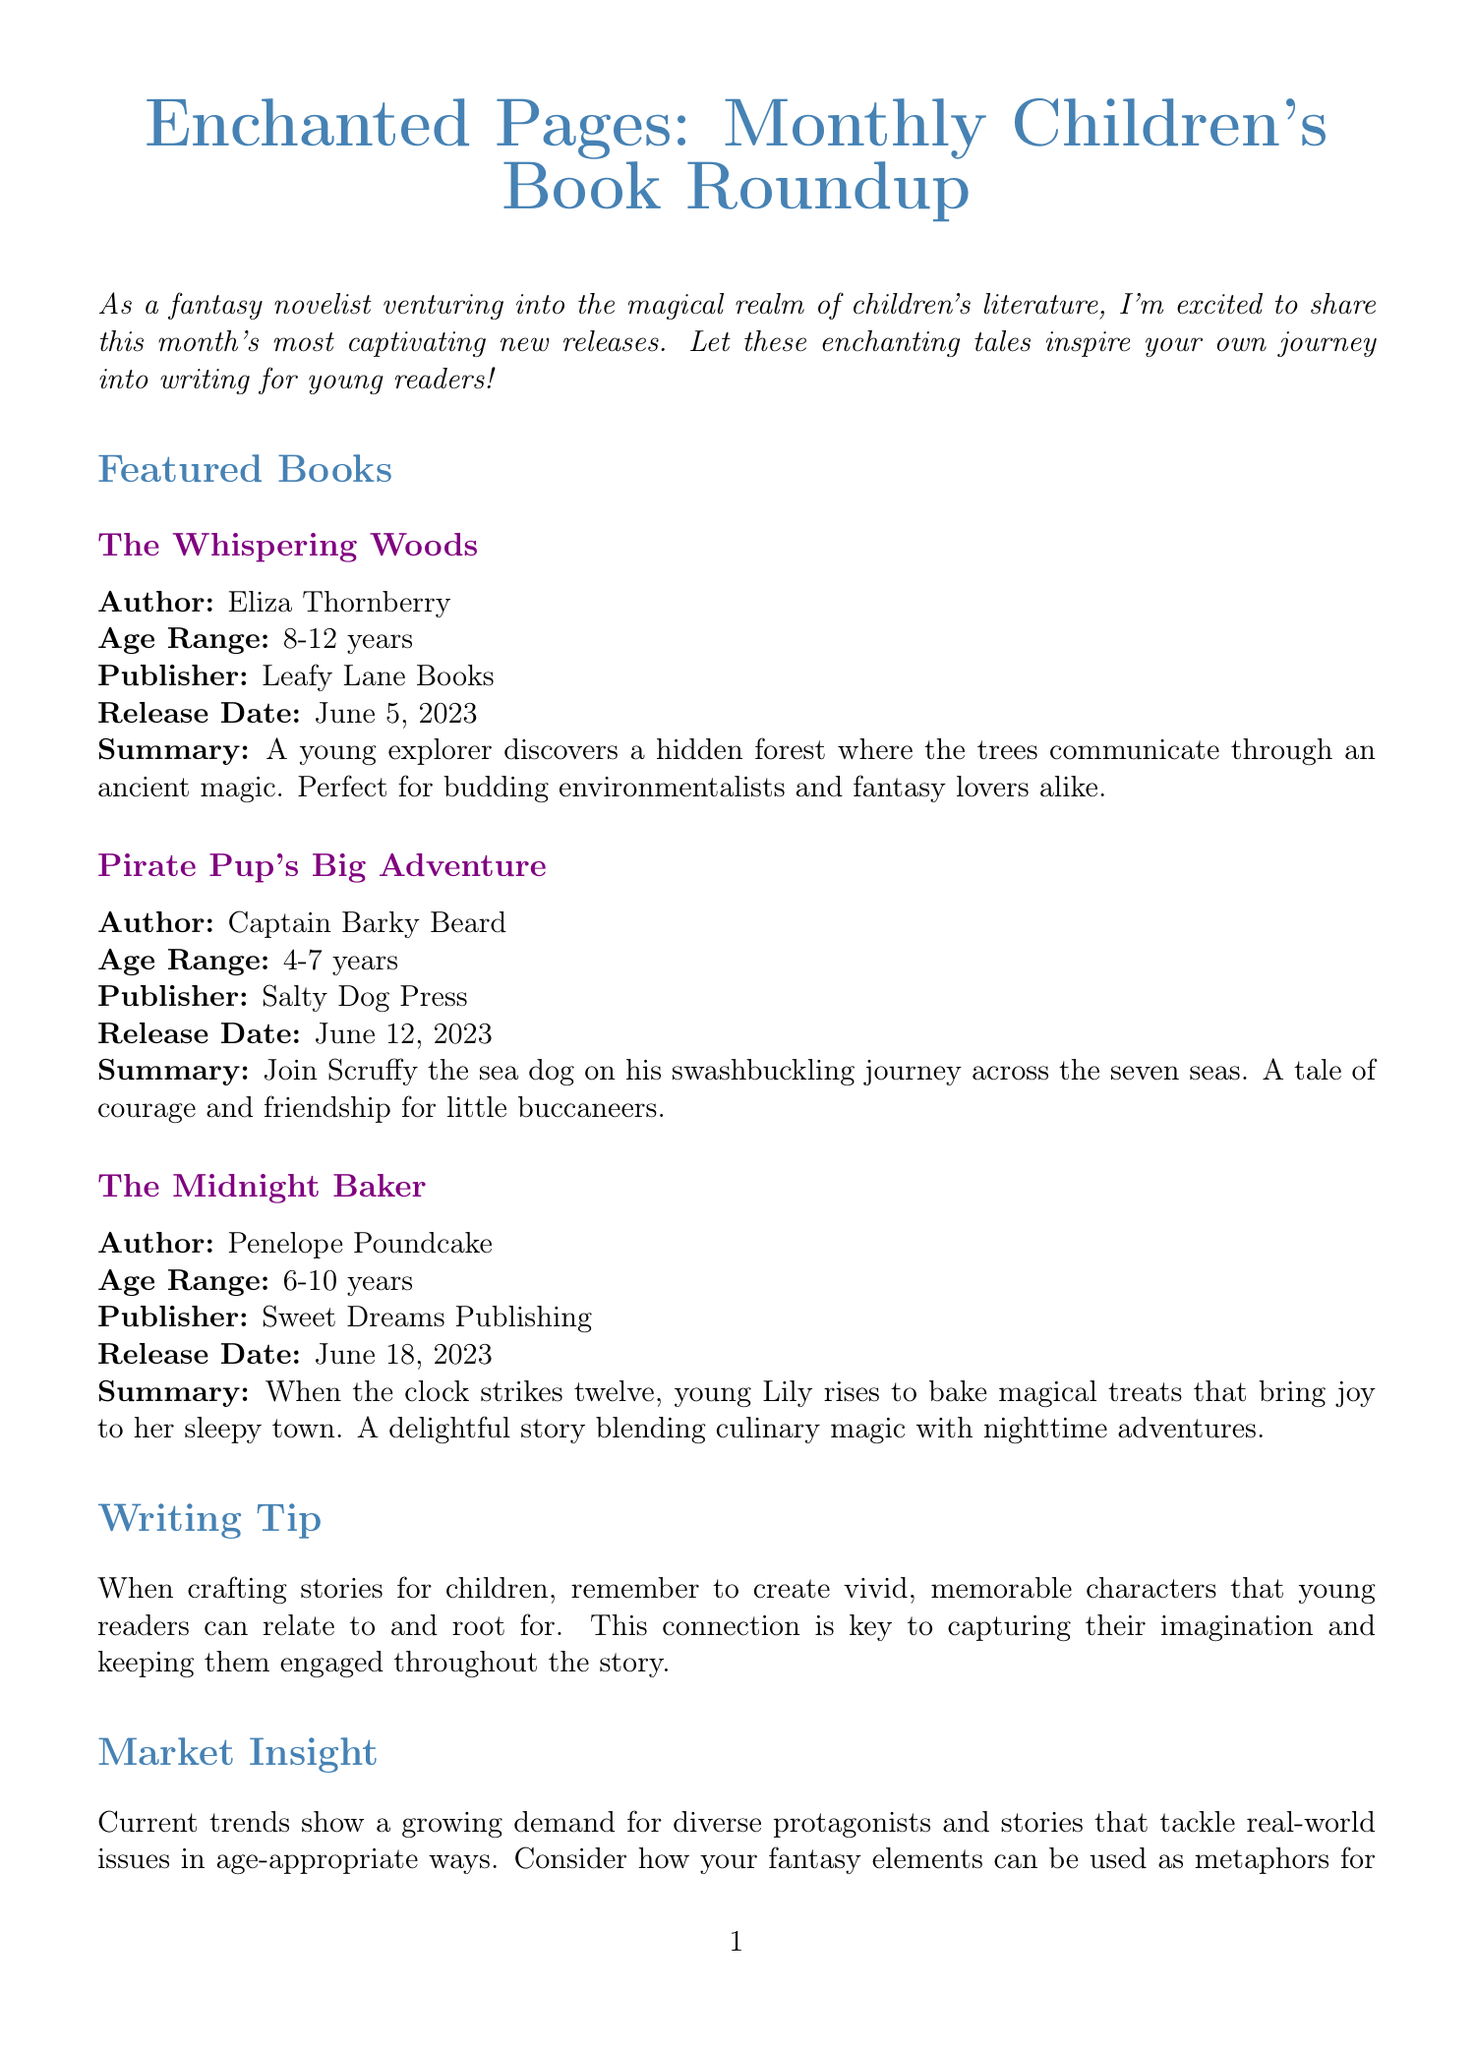What is the title of this newsletter? The title of the newsletter is provided at the beginning of the document.
Answer: Enchanted Pages: Monthly Children's Book Roundup Who is the author of "The Midnight Baker"? The author's name is listed alongside each featured book summary in the document.
Answer: Penelope Poundcake What is the release date of "Pirate Pup's Big Adventure"? The release date is specified for each featured book in the document.
Answer: June 12, 2023 What age range is "The Whispering Woods" targeted at? The age range is mentioned in each book's summary section.
Answer: 8-12 years What key element is important for engaging young readers according to the writing tip? The writing tip section highlights what is essential for writing compelling stories for children.
Answer: Vivid, memorable characters Which upcoming event is mentioned in the newsletter? The upcoming events section lists the specific event details.
Answer: Storybook Summer Festival How many featured books are in this month's newsletter? Counting the entries in the featured books section gives the number of books.
Answer: Three What is the hashtag for reader engagement? The hashtag can be found in the reader engagement section of the document.
Answer: #ChildhoodBookMemories What is a current trend in children's literature as noted in the market insight? The market insight section discusses trends relevant to children's books.
Answer: Diverse protagonists 